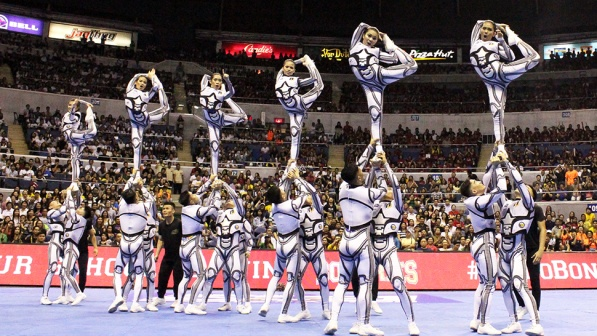Can you describe the uniforms of the cheerleaders? The cheerleaders are wearing stylish white uniforms with blue accents. The design includes intricate patterns that give a futuristic look, reminiscent of something you might see in a sci-fi movie. The uniforms are form-fitting, allowing for ease of movement, which is essential for their complex stunts. The blue lines highlight their figures and add a vibrant contrast to the predominately white outfit, elevating their appearance during the performance. 